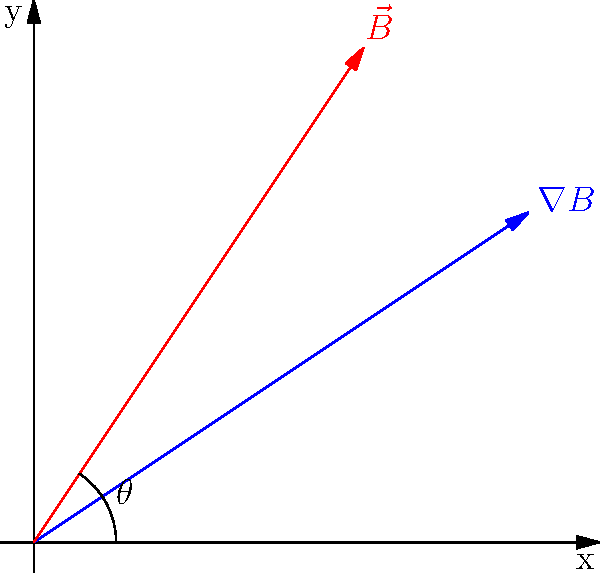In MRI imaging of the brain, the relationship between the magnetic field gradient vector $\nabla B$ and the main magnetic field vector $\vec{B}$ is crucial. Given the vectors shown in the diagram, calculate the angle $\theta$ between $\nabla B$ and $\vec{B}$. How might this angle affect the clarity of brain images in your recent surgery? To find the angle between the gradient vector $\nabla B$ and the magnetic field vector $\vec{B}$, we'll use the dot product formula:

1) The dot product formula: $\cos \theta = \frac{\vec{a} \cdot \vec{b}}{|\vec{a}||\vec{b}|}$

2) From the diagram:
   $\nabla B = (3, 2)$
   $\vec{B} = (2, 3)$

3) Calculate the dot product:
   $\nabla B \cdot \vec{B} = 3(2) + 2(3) = 6 + 6 = 12$

4) Calculate the magnitudes:
   $|\nabla B| = \sqrt{3^2 + 2^2} = \sqrt{13}$
   $|\vec{B}| = \sqrt{2^2 + 3^2} = \sqrt{13}$

5) Apply the formula:
   $\cos \theta = \frac{12}{\sqrt{13}\sqrt{13}} = \frac{12}{13}$

6) Take the inverse cosine (arccos) to find $\theta$:
   $\theta = \arccos(\frac{12}{13}) \approx 22.6°$

The angle between the gradient and the main magnetic field affects the spatial encoding of the MRI signal. A smaller angle (closer to parallel vectors) would result in less distinct spatial information, potentially reducing the clarity of brain images. The calculated angle of about 22.6° allows for good spatial encoding, which likely contributed to clear images during your recent brain surgery.
Answer: $\theta \approx 22.6°$ 